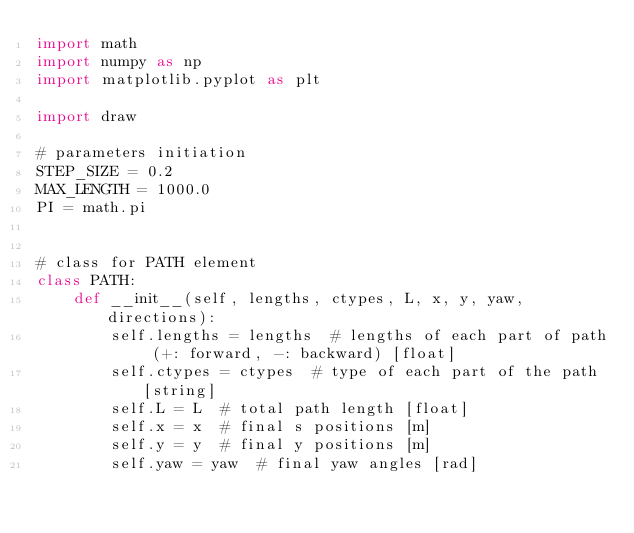Convert code to text. <code><loc_0><loc_0><loc_500><loc_500><_Python_>import math
import numpy as np
import matplotlib.pyplot as plt

import draw

# parameters initiation
STEP_SIZE = 0.2
MAX_LENGTH = 1000.0
PI = math.pi


# class for PATH element
class PATH:
    def __init__(self, lengths, ctypes, L, x, y, yaw, directions):
        self.lengths = lengths  # lengths of each part of path (+: forward, -: backward) [float]
        self.ctypes = ctypes  # type of each part of the path [string]
        self.L = L  # total path length [float]
        self.x = x  # final s positions [m]
        self.y = y  # final y positions [m]
        self.yaw = yaw  # final yaw angles [rad]</code> 